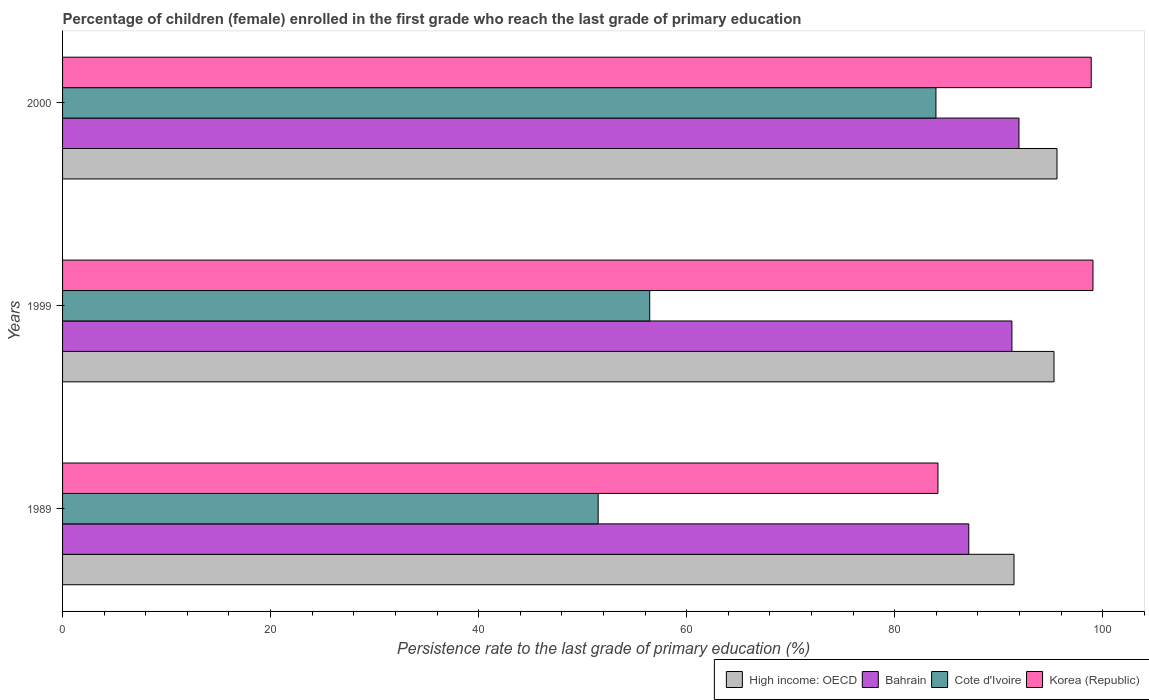How many different coloured bars are there?
Keep it short and to the point. 4. How many groups of bars are there?
Your answer should be very brief. 3. Are the number of bars on each tick of the Y-axis equal?
Keep it short and to the point. Yes. How many bars are there on the 3rd tick from the bottom?
Provide a succinct answer. 4. In how many cases, is the number of bars for a given year not equal to the number of legend labels?
Offer a very short reply. 0. What is the persistence rate of children in Cote d'Ivoire in 1989?
Offer a terse response. 51.49. Across all years, what is the maximum persistence rate of children in Bahrain?
Offer a terse response. 91.95. Across all years, what is the minimum persistence rate of children in High income: OECD?
Make the answer very short. 91.47. In which year was the persistence rate of children in High income: OECD maximum?
Keep it short and to the point. 2000. What is the total persistence rate of children in Cote d'Ivoire in the graph?
Keep it short and to the point. 191.91. What is the difference between the persistence rate of children in High income: OECD in 1989 and that in 1999?
Make the answer very short. -3.85. What is the difference between the persistence rate of children in Cote d'Ivoire in 2000 and the persistence rate of children in Bahrain in 1989?
Make the answer very short. -3.16. What is the average persistence rate of children in Korea (Republic) per year?
Offer a very short reply. 94.04. In the year 1999, what is the difference between the persistence rate of children in Bahrain and persistence rate of children in High income: OECD?
Give a very brief answer. -4.05. What is the ratio of the persistence rate of children in Bahrain in 1999 to that in 2000?
Your answer should be compact. 0.99. Is the difference between the persistence rate of children in Bahrain in 1989 and 2000 greater than the difference between the persistence rate of children in High income: OECD in 1989 and 2000?
Offer a terse response. No. What is the difference between the highest and the second highest persistence rate of children in Bahrain?
Offer a terse response. 0.68. What is the difference between the highest and the lowest persistence rate of children in Korea (Republic)?
Your answer should be very brief. 14.9. Is the sum of the persistence rate of children in Bahrain in 1999 and 2000 greater than the maximum persistence rate of children in Cote d'Ivoire across all years?
Make the answer very short. Yes. What does the 2nd bar from the bottom in 1989 represents?
Offer a terse response. Bahrain. Is it the case that in every year, the sum of the persistence rate of children in Cote d'Ivoire and persistence rate of children in Bahrain is greater than the persistence rate of children in High income: OECD?
Offer a terse response. Yes. Are all the bars in the graph horizontal?
Make the answer very short. Yes. How many years are there in the graph?
Ensure brevity in your answer.  3. Does the graph contain any zero values?
Provide a succinct answer. No. Where does the legend appear in the graph?
Give a very brief answer. Bottom right. How many legend labels are there?
Your answer should be very brief. 4. What is the title of the graph?
Offer a very short reply. Percentage of children (female) enrolled in the first grade who reach the last grade of primary education. What is the label or title of the X-axis?
Give a very brief answer. Persistence rate to the last grade of primary education (%). What is the Persistence rate to the last grade of primary education (%) in High income: OECD in 1989?
Your response must be concise. 91.47. What is the Persistence rate to the last grade of primary education (%) of Bahrain in 1989?
Your answer should be very brief. 87.13. What is the Persistence rate to the last grade of primary education (%) of Cote d'Ivoire in 1989?
Provide a succinct answer. 51.49. What is the Persistence rate to the last grade of primary education (%) in Korea (Republic) in 1989?
Provide a succinct answer. 84.16. What is the Persistence rate to the last grade of primary education (%) in High income: OECD in 1999?
Offer a very short reply. 95.32. What is the Persistence rate to the last grade of primary education (%) of Bahrain in 1999?
Your answer should be compact. 91.27. What is the Persistence rate to the last grade of primary education (%) in Cote d'Ivoire in 1999?
Offer a very short reply. 56.45. What is the Persistence rate to the last grade of primary education (%) of Korea (Republic) in 1999?
Your answer should be compact. 99.07. What is the Persistence rate to the last grade of primary education (%) of High income: OECD in 2000?
Provide a succinct answer. 95.61. What is the Persistence rate to the last grade of primary education (%) of Bahrain in 2000?
Your answer should be compact. 91.95. What is the Persistence rate to the last grade of primary education (%) in Cote d'Ivoire in 2000?
Make the answer very short. 83.97. What is the Persistence rate to the last grade of primary education (%) in Korea (Republic) in 2000?
Your response must be concise. 98.9. Across all years, what is the maximum Persistence rate to the last grade of primary education (%) of High income: OECD?
Give a very brief answer. 95.61. Across all years, what is the maximum Persistence rate to the last grade of primary education (%) in Bahrain?
Provide a succinct answer. 91.95. Across all years, what is the maximum Persistence rate to the last grade of primary education (%) in Cote d'Ivoire?
Give a very brief answer. 83.97. Across all years, what is the maximum Persistence rate to the last grade of primary education (%) of Korea (Republic)?
Offer a very short reply. 99.07. Across all years, what is the minimum Persistence rate to the last grade of primary education (%) in High income: OECD?
Give a very brief answer. 91.47. Across all years, what is the minimum Persistence rate to the last grade of primary education (%) of Bahrain?
Offer a terse response. 87.13. Across all years, what is the minimum Persistence rate to the last grade of primary education (%) of Cote d'Ivoire?
Your answer should be very brief. 51.49. Across all years, what is the minimum Persistence rate to the last grade of primary education (%) in Korea (Republic)?
Your answer should be very brief. 84.16. What is the total Persistence rate to the last grade of primary education (%) in High income: OECD in the graph?
Offer a terse response. 282.4. What is the total Persistence rate to the last grade of primary education (%) of Bahrain in the graph?
Your response must be concise. 270.35. What is the total Persistence rate to the last grade of primary education (%) of Cote d'Ivoire in the graph?
Provide a short and direct response. 191.91. What is the total Persistence rate to the last grade of primary education (%) of Korea (Republic) in the graph?
Give a very brief answer. 282.13. What is the difference between the Persistence rate to the last grade of primary education (%) in High income: OECD in 1989 and that in 1999?
Offer a very short reply. -3.85. What is the difference between the Persistence rate to the last grade of primary education (%) of Bahrain in 1989 and that in 1999?
Ensure brevity in your answer.  -4.15. What is the difference between the Persistence rate to the last grade of primary education (%) of Cote d'Ivoire in 1989 and that in 1999?
Your answer should be very brief. -4.96. What is the difference between the Persistence rate to the last grade of primary education (%) of Korea (Republic) in 1989 and that in 1999?
Your response must be concise. -14.9. What is the difference between the Persistence rate to the last grade of primary education (%) in High income: OECD in 1989 and that in 2000?
Ensure brevity in your answer.  -4.13. What is the difference between the Persistence rate to the last grade of primary education (%) of Bahrain in 1989 and that in 2000?
Your answer should be very brief. -4.82. What is the difference between the Persistence rate to the last grade of primary education (%) of Cote d'Ivoire in 1989 and that in 2000?
Make the answer very short. -32.48. What is the difference between the Persistence rate to the last grade of primary education (%) of Korea (Republic) in 1989 and that in 2000?
Keep it short and to the point. -14.73. What is the difference between the Persistence rate to the last grade of primary education (%) of High income: OECD in 1999 and that in 2000?
Keep it short and to the point. -0.29. What is the difference between the Persistence rate to the last grade of primary education (%) of Bahrain in 1999 and that in 2000?
Keep it short and to the point. -0.68. What is the difference between the Persistence rate to the last grade of primary education (%) of Cote d'Ivoire in 1999 and that in 2000?
Ensure brevity in your answer.  -27.52. What is the difference between the Persistence rate to the last grade of primary education (%) of Korea (Republic) in 1999 and that in 2000?
Keep it short and to the point. 0.17. What is the difference between the Persistence rate to the last grade of primary education (%) of High income: OECD in 1989 and the Persistence rate to the last grade of primary education (%) of Bahrain in 1999?
Offer a terse response. 0.2. What is the difference between the Persistence rate to the last grade of primary education (%) of High income: OECD in 1989 and the Persistence rate to the last grade of primary education (%) of Cote d'Ivoire in 1999?
Give a very brief answer. 35.02. What is the difference between the Persistence rate to the last grade of primary education (%) of High income: OECD in 1989 and the Persistence rate to the last grade of primary education (%) of Korea (Republic) in 1999?
Your answer should be very brief. -7.59. What is the difference between the Persistence rate to the last grade of primary education (%) in Bahrain in 1989 and the Persistence rate to the last grade of primary education (%) in Cote d'Ivoire in 1999?
Ensure brevity in your answer.  30.68. What is the difference between the Persistence rate to the last grade of primary education (%) in Bahrain in 1989 and the Persistence rate to the last grade of primary education (%) in Korea (Republic) in 1999?
Keep it short and to the point. -11.94. What is the difference between the Persistence rate to the last grade of primary education (%) in Cote d'Ivoire in 1989 and the Persistence rate to the last grade of primary education (%) in Korea (Republic) in 1999?
Your answer should be compact. -47.57. What is the difference between the Persistence rate to the last grade of primary education (%) in High income: OECD in 1989 and the Persistence rate to the last grade of primary education (%) in Bahrain in 2000?
Give a very brief answer. -0.48. What is the difference between the Persistence rate to the last grade of primary education (%) of High income: OECD in 1989 and the Persistence rate to the last grade of primary education (%) of Cote d'Ivoire in 2000?
Offer a very short reply. 7.5. What is the difference between the Persistence rate to the last grade of primary education (%) in High income: OECD in 1989 and the Persistence rate to the last grade of primary education (%) in Korea (Republic) in 2000?
Provide a short and direct response. -7.42. What is the difference between the Persistence rate to the last grade of primary education (%) in Bahrain in 1989 and the Persistence rate to the last grade of primary education (%) in Cote d'Ivoire in 2000?
Offer a very short reply. 3.16. What is the difference between the Persistence rate to the last grade of primary education (%) in Bahrain in 1989 and the Persistence rate to the last grade of primary education (%) in Korea (Republic) in 2000?
Provide a succinct answer. -11.77. What is the difference between the Persistence rate to the last grade of primary education (%) in Cote d'Ivoire in 1989 and the Persistence rate to the last grade of primary education (%) in Korea (Republic) in 2000?
Make the answer very short. -47.4. What is the difference between the Persistence rate to the last grade of primary education (%) in High income: OECD in 1999 and the Persistence rate to the last grade of primary education (%) in Bahrain in 2000?
Ensure brevity in your answer.  3.37. What is the difference between the Persistence rate to the last grade of primary education (%) in High income: OECD in 1999 and the Persistence rate to the last grade of primary education (%) in Cote d'Ivoire in 2000?
Your response must be concise. 11.35. What is the difference between the Persistence rate to the last grade of primary education (%) of High income: OECD in 1999 and the Persistence rate to the last grade of primary education (%) of Korea (Republic) in 2000?
Provide a succinct answer. -3.58. What is the difference between the Persistence rate to the last grade of primary education (%) of Bahrain in 1999 and the Persistence rate to the last grade of primary education (%) of Cote d'Ivoire in 2000?
Offer a very short reply. 7.3. What is the difference between the Persistence rate to the last grade of primary education (%) of Bahrain in 1999 and the Persistence rate to the last grade of primary education (%) of Korea (Republic) in 2000?
Provide a succinct answer. -7.62. What is the difference between the Persistence rate to the last grade of primary education (%) in Cote d'Ivoire in 1999 and the Persistence rate to the last grade of primary education (%) in Korea (Republic) in 2000?
Provide a short and direct response. -42.45. What is the average Persistence rate to the last grade of primary education (%) of High income: OECD per year?
Ensure brevity in your answer.  94.13. What is the average Persistence rate to the last grade of primary education (%) of Bahrain per year?
Ensure brevity in your answer.  90.12. What is the average Persistence rate to the last grade of primary education (%) of Cote d'Ivoire per year?
Provide a short and direct response. 63.97. What is the average Persistence rate to the last grade of primary education (%) of Korea (Republic) per year?
Your response must be concise. 94.04. In the year 1989, what is the difference between the Persistence rate to the last grade of primary education (%) in High income: OECD and Persistence rate to the last grade of primary education (%) in Bahrain?
Ensure brevity in your answer.  4.35. In the year 1989, what is the difference between the Persistence rate to the last grade of primary education (%) in High income: OECD and Persistence rate to the last grade of primary education (%) in Cote d'Ivoire?
Provide a short and direct response. 39.98. In the year 1989, what is the difference between the Persistence rate to the last grade of primary education (%) in High income: OECD and Persistence rate to the last grade of primary education (%) in Korea (Republic)?
Give a very brief answer. 7.31. In the year 1989, what is the difference between the Persistence rate to the last grade of primary education (%) in Bahrain and Persistence rate to the last grade of primary education (%) in Cote d'Ivoire?
Offer a terse response. 35.63. In the year 1989, what is the difference between the Persistence rate to the last grade of primary education (%) in Bahrain and Persistence rate to the last grade of primary education (%) in Korea (Republic)?
Ensure brevity in your answer.  2.96. In the year 1989, what is the difference between the Persistence rate to the last grade of primary education (%) of Cote d'Ivoire and Persistence rate to the last grade of primary education (%) of Korea (Republic)?
Provide a short and direct response. -32.67. In the year 1999, what is the difference between the Persistence rate to the last grade of primary education (%) of High income: OECD and Persistence rate to the last grade of primary education (%) of Bahrain?
Your answer should be very brief. 4.05. In the year 1999, what is the difference between the Persistence rate to the last grade of primary education (%) of High income: OECD and Persistence rate to the last grade of primary education (%) of Cote d'Ivoire?
Your answer should be very brief. 38.87. In the year 1999, what is the difference between the Persistence rate to the last grade of primary education (%) in High income: OECD and Persistence rate to the last grade of primary education (%) in Korea (Republic)?
Ensure brevity in your answer.  -3.75. In the year 1999, what is the difference between the Persistence rate to the last grade of primary education (%) of Bahrain and Persistence rate to the last grade of primary education (%) of Cote d'Ivoire?
Offer a very short reply. 34.82. In the year 1999, what is the difference between the Persistence rate to the last grade of primary education (%) of Bahrain and Persistence rate to the last grade of primary education (%) of Korea (Republic)?
Your response must be concise. -7.79. In the year 1999, what is the difference between the Persistence rate to the last grade of primary education (%) of Cote d'Ivoire and Persistence rate to the last grade of primary education (%) of Korea (Republic)?
Give a very brief answer. -42.62. In the year 2000, what is the difference between the Persistence rate to the last grade of primary education (%) of High income: OECD and Persistence rate to the last grade of primary education (%) of Bahrain?
Ensure brevity in your answer.  3.66. In the year 2000, what is the difference between the Persistence rate to the last grade of primary education (%) in High income: OECD and Persistence rate to the last grade of primary education (%) in Cote d'Ivoire?
Keep it short and to the point. 11.64. In the year 2000, what is the difference between the Persistence rate to the last grade of primary education (%) of High income: OECD and Persistence rate to the last grade of primary education (%) of Korea (Republic)?
Offer a very short reply. -3.29. In the year 2000, what is the difference between the Persistence rate to the last grade of primary education (%) in Bahrain and Persistence rate to the last grade of primary education (%) in Cote d'Ivoire?
Make the answer very short. 7.98. In the year 2000, what is the difference between the Persistence rate to the last grade of primary education (%) in Bahrain and Persistence rate to the last grade of primary education (%) in Korea (Republic)?
Give a very brief answer. -6.95. In the year 2000, what is the difference between the Persistence rate to the last grade of primary education (%) of Cote d'Ivoire and Persistence rate to the last grade of primary education (%) of Korea (Republic)?
Ensure brevity in your answer.  -14.93. What is the ratio of the Persistence rate to the last grade of primary education (%) of High income: OECD in 1989 to that in 1999?
Offer a very short reply. 0.96. What is the ratio of the Persistence rate to the last grade of primary education (%) of Bahrain in 1989 to that in 1999?
Give a very brief answer. 0.95. What is the ratio of the Persistence rate to the last grade of primary education (%) of Cote d'Ivoire in 1989 to that in 1999?
Ensure brevity in your answer.  0.91. What is the ratio of the Persistence rate to the last grade of primary education (%) in Korea (Republic) in 1989 to that in 1999?
Your answer should be very brief. 0.85. What is the ratio of the Persistence rate to the last grade of primary education (%) of High income: OECD in 1989 to that in 2000?
Give a very brief answer. 0.96. What is the ratio of the Persistence rate to the last grade of primary education (%) of Bahrain in 1989 to that in 2000?
Offer a terse response. 0.95. What is the ratio of the Persistence rate to the last grade of primary education (%) of Cote d'Ivoire in 1989 to that in 2000?
Provide a succinct answer. 0.61. What is the ratio of the Persistence rate to the last grade of primary education (%) in Korea (Republic) in 1989 to that in 2000?
Your response must be concise. 0.85. What is the ratio of the Persistence rate to the last grade of primary education (%) of Bahrain in 1999 to that in 2000?
Make the answer very short. 0.99. What is the ratio of the Persistence rate to the last grade of primary education (%) in Cote d'Ivoire in 1999 to that in 2000?
Ensure brevity in your answer.  0.67. What is the ratio of the Persistence rate to the last grade of primary education (%) of Korea (Republic) in 1999 to that in 2000?
Offer a terse response. 1. What is the difference between the highest and the second highest Persistence rate to the last grade of primary education (%) in High income: OECD?
Give a very brief answer. 0.29. What is the difference between the highest and the second highest Persistence rate to the last grade of primary education (%) in Bahrain?
Your answer should be compact. 0.68. What is the difference between the highest and the second highest Persistence rate to the last grade of primary education (%) in Cote d'Ivoire?
Your answer should be compact. 27.52. What is the difference between the highest and the second highest Persistence rate to the last grade of primary education (%) in Korea (Republic)?
Provide a succinct answer. 0.17. What is the difference between the highest and the lowest Persistence rate to the last grade of primary education (%) of High income: OECD?
Offer a very short reply. 4.13. What is the difference between the highest and the lowest Persistence rate to the last grade of primary education (%) in Bahrain?
Provide a short and direct response. 4.82. What is the difference between the highest and the lowest Persistence rate to the last grade of primary education (%) in Cote d'Ivoire?
Provide a short and direct response. 32.48. What is the difference between the highest and the lowest Persistence rate to the last grade of primary education (%) in Korea (Republic)?
Your answer should be very brief. 14.9. 